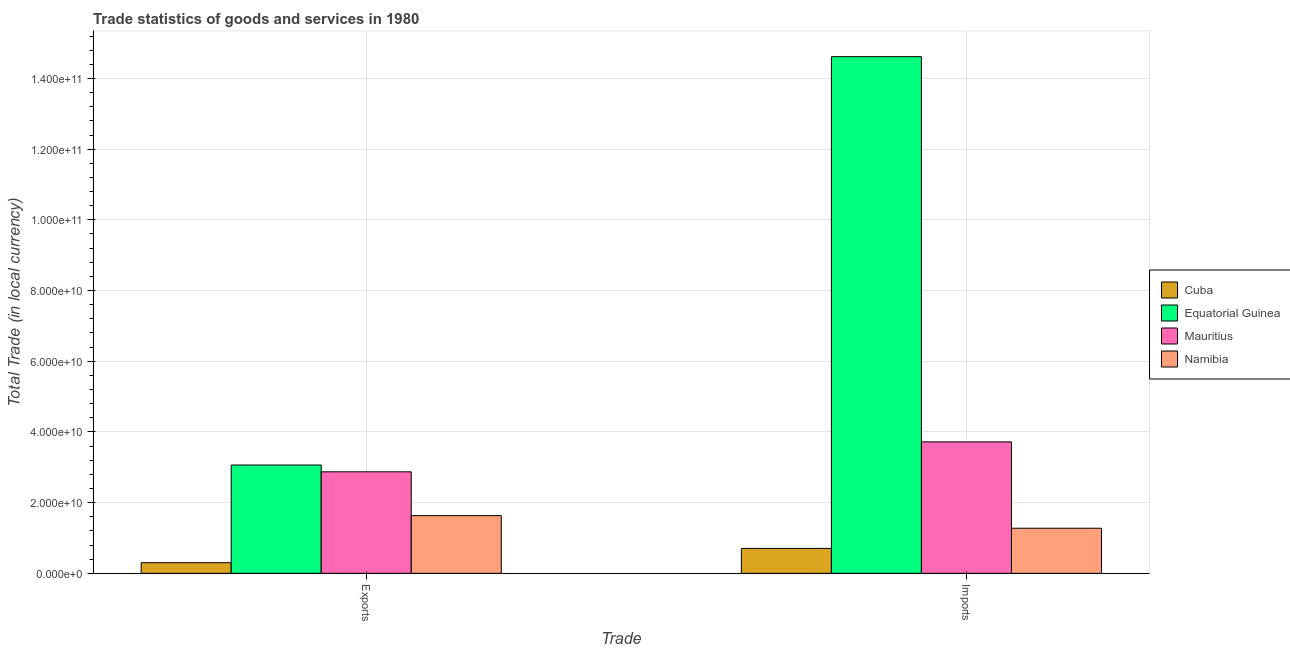How many groups of bars are there?
Provide a succinct answer. 2. Are the number of bars per tick equal to the number of legend labels?
Offer a very short reply. Yes. Are the number of bars on each tick of the X-axis equal?
Make the answer very short. Yes. How many bars are there on the 1st tick from the left?
Offer a terse response. 4. How many bars are there on the 2nd tick from the right?
Your response must be concise. 4. What is the label of the 2nd group of bars from the left?
Your response must be concise. Imports. What is the export of goods and services in Cuba?
Ensure brevity in your answer.  3.01e+09. Across all countries, what is the maximum imports of goods and services?
Offer a terse response. 1.46e+11. Across all countries, what is the minimum imports of goods and services?
Your answer should be very brief. 7.05e+09. In which country was the export of goods and services maximum?
Offer a terse response. Equatorial Guinea. In which country was the export of goods and services minimum?
Offer a very short reply. Cuba. What is the total imports of goods and services in the graph?
Offer a terse response. 2.03e+11. What is the difference between the imports of goods and services in Namibia and that in Mauritius?
Your response must be concise. -2.44e+1. What is the difference between the imports of goods and services in Mauritius and the export of goods and services in Namibia?
Your response must be concise. 2.09e+1. What is the average export of goods and services per country?
Provide a succinct answer. 1.97e+1. What is the difference between the export of goods and services and imports of goods and services in Cuba?
Ensure brevity in your answer.  -4.04e+09. What is the ratio of the imports of goods and services in Equatorial Guinea to that in Namibia?
Provide a short and direct response. 11.45. Is the export of goods and services in Cuba less than that in Mauritius?
Provide a succinct answer. Yes. In how many countries, is the export of goods and services greater than the average export of goods and services taken over all countries?
Provide a succinct answer. 2. What does the 4th bar from the left in Imports represents?
Ensure brevity in your answer.  Namibia. What does the 1st bar from the right in Imports represents?
Your answer should be compact. Namibia. How many bars are there?
Your response must be concise. 8. Are all the bars in the graph horizontal?
Offer a terse response. No. What is the difference between two consecutive major ticks on the Y-axis?
Offer a terse response. 2.00e+1. Does the graph contain any zero values?
Give a very brief answer. No. Does the graph contain grids?
Make the answer very short. Yes. How many legend labels are there?
Provide a short and direct response. 4. What is the title of the graph?
Your response must be concise. Trade statistics of goods and services in 1980. What is the label or title of the X-axis?
Offer a terse response. Trade. What is the label or title of the Y-axis?
Offer a terse response. Total Trade (in local currency). What is the Total Trade (in local currency) in Cuba in Exports?
Ensure brevity in your answer.  3.01e+09. What is the Total Trade (in local currency) of Equatorial Guinea in Exports?
Ensure brevity in your answer.  3.06e+1. What is the Total Trade (in local currency) in Mauritius in Exports?
Provide a short and direct response. 2.87e+1. What is the Total Trade (in local currency) in Namibia in Exports?
Ensure brevity in your answer.  1.63e+1. What is the Total Trade (in local currency) of Cuba in Imports?
Make the answer very short. 7.05e+09. What is the Total Trade (in local currency) in Equatorial Guinea in Imports?
Your answer should be compact. 1.46e+11. What is the Total Trade (in local currency) in Mauritius in Imports?
Your answer should be very brief. 3.72e+1. What is the Total Trade (in local currency) of Namibia in Imports?
Give a very brief answer. 1.28e+1. Across all Trade, what is the maximum Total Trade (in local currency) in Cuba?
Keep it short and to the point. 7.05e+09. Across all Trade, what is the maximum Total Trade (in local currency) of Equatorial Guinea?
Make the answer very short. 1.46e+11. Across all Trade, what is the maximum Total Trade (in local currency) in Mauritius?
Your answer should be compact. 3.72e+1. Across all Trade, what is the maximum Total Trade (in local currency) of Namibia?
Ensure brevity in your answer.  1.63e+1. Across all Trade, what is the minimum Total Trade (in local currency) of Cuba?
Make the answer very short. 3.01e+09. Across all Trade, what is the minimum Total Trade (in local currency) in Equatorial Guinea?
Give a very brief answer. 3.06e+1. Across all Trade, what is the minimum Total Trade (in local currency) of Mauritius?
Give a very brief answer. 2.87e+1. Across all Trade, what is the minimum Total Trade (in local currency) of Namibia?
Give a very brief answer. 1.28e+1. What is the total Total Trade (in local currency) of Cuba in the graph?
Your response must be concise. 1.01e+1. What is the total Total Trade (in local currency) of Equatorial Guinea in the graph?
Offer a very short reply. 1.77e+11. What is the total Total Trade (in local currency) of Mauritius in the graph?
Your response must be concise. 6.59e+1. What is the total Total Trade (in local currency) in Namibia in the graph?
Provide a short and direct response. 2.91e+1. What is the difference between the Total Trade (in local currency) of Cuba in Exports and that in Imports?
Offer a very short reply. -4.04e+09. What is the difference between the Total Trade (in local currency) in Equatorial Guinea in Exports and that in Imports?
Give a very brief answer. -1.16e+11. What is the difference between the Total Trade (in local currency) in Mauritius in Exports and that in Imports?
Provide a succinct answer. -8.47e+09. What is the difference between the Total Trade (in local currency) in Namibia in Exports and that in Imports?
Make the answer very short. 3.57e+09. What is the difference between the Total Trade (in local currency) of Cuba in Exports and the Total Trade (in local currency) of Equatorial Guinea in Imports?
Offer a terse response. -1.43e+11. What is the difference between the Total Trade (in local currency) in Cuba in Exports and the Total Trade (in local currency) in Mauritius in Imports?
Give a very brief answer. -3.42e+1. What is the difference between the Total Trade (in local currency) of Cuba in Exports and the Total Trade (in local currency) of Namibia in Imports?
Give a very brief answer. -9.75e+09. What is the difference between the Total Trade (in local currency) in Equatorial Guinea in Exports and the Total Trade (in local currency) in Mauritius in Imports?
Give a very brief answer. -6.55e+09. What is the difference between the Total Trade (in local currency) in Equatorial Guinea in Exports and the Total Trade (in local currency) in Namibia in Imports?
Provide a short and direct response. 1.79e+1. What is the difference between the Total Trade (in local currency) of Mauritius in Exports and the Total Trade (in local currency) of Namibia in Imports?
Offer a terse response. 1.60e+1. What is the average Total Trade (in local currency) of Cuba per Trade?
Give a very brief answer. 5.03e+09. What is the average Total Trade (in local currency) in Equatorial Guinea per Trade?
Your answer should be compact. 8.84e+1. What is the average Total Trade (in local currency) in Mauritius per Trade?
Ensure brevity in your answer.  3.30e+1. What is the average Total Trade (in local currency) in Namibia per Trade?
Ensure brevity in your answer.  1.45e+1. What is the difference between the Total Trade (in local currency) in Cuba and Total Trade (in local currency) in Equatorial Guinea in Exports?
Give a very brief answer. -2.76e+1. What is the difference between the Total Trade (in local currency) in Cuba and Total Trade (in local currency) in Mauritius in Exports?
Make the answer very short. -2.57e+1. What is the difference between the Total Trade (in local currency) of Cuba and Total Trade (in local currency) of Namibia in Exports?
Make the answer very short. -1.33e+1. What is the difference between the Total Trade (in local currency) in Equatorial Guinea and Total Trade (in local currency) in Mauritius in Exports?
Make the answer very short. 1.92e+09. What is the difference between the Total Trade (in local currency) in Equatorial Guinea and Total Trade (in local currency) in Namibia in Exports?
Keep it short and to the point. 1.43e+1. What is the difference between the Total Trade (in local currency) in Mauritius and Total Trade (in local currency) in Namibia in Exports?
Offer a very short reply. 1.24e+1. What is the difference between the Total Trade (in local currency) in Cuba and Total Trade (in local currency) in Equatorial Guinea in Imports?
Give a very brief answer. -1.39e+11. What is the difference between the Total Trade (in local currency) in Cuba and Total Trade (in local currency) in Mauritius in Imports?
Ensure brevity in your answer.  -3.01e+1. What is the difference between the Total Trade (in local currency) in Cuba and Total Trade (in local currency) in Namibia in Imports?
Make the answer very short. -5.71e+09. What is the difference between the Total Trade (in local currency) of Equatorial Guinea and Total Trade (in local currency) of Mauritius in Imports?
Give a very brief answer. 1.09e+11. What is the difference between the Total Trade (in local currency) in Equatorial Guinea and Total Trade (in local currency) in Namibia in Imports?
Ensure brevity in your answer.  1.33e+11. What is the difference between the Total Trade (in local currency) in Mauritius and Total Trade (in local currency) in Namibia in Imports?
Offer a very short reply. 2.44e+1. What is the ratio of the Total Trade (in local currency) of Cuba in Exports to that in Imports?
Your answer should be very brief. 0.43. What is the ratio of the Total Trade (in local currency) in Equatorial Guinea in Exports to that in Imports?
Offer a very short reply. 0.21. What is the ratio of the Total Trade (in local currency) of Mauritius in Exports to that in Imports?
Keep it short and to the point. 0.77. What is the ratio of the Total Trade (in local currency) of Namibia in Exports to that in Imports?
Offer a very short reply. 1.28. What is the difference between the highest and the second highest Total Trade (in local currency) in Cuba?
Your answer should be very brief. 4.04e+09. What is the difference between the highest and the second highest Total Trade (in local currency) of Equatorial Guinea?
Your response must be concise. 1.16e+11. What is the difference between the highest and the second highest Total Trade (in local currency) in Mauritius?
Keep it short and to the point. 8.47e+09. What is the difference between the highest and the second highest Total Trade (in local currency) in Namibia?
Your answer should be compact. 3.57e+09. What is the difference between the highest and the lowest Total Trade (in local currency) in Cuba?
Your response must be concise. 4.04e+09. What is the difference between the highest and the lowest Total Trade (in local currency) of Equatorial Guinea?
Make the answer very short. 1.16e+11. What is the difference between the highest and the lowest Total Trade (in local currency) of Mauritius?
Ensure brevity in your answer.  8.47e+09. What is the difference between the highest and the lowest Total Trade (in local currency) in Namibia?
Your answer should be very brief. 3.57e+09. 